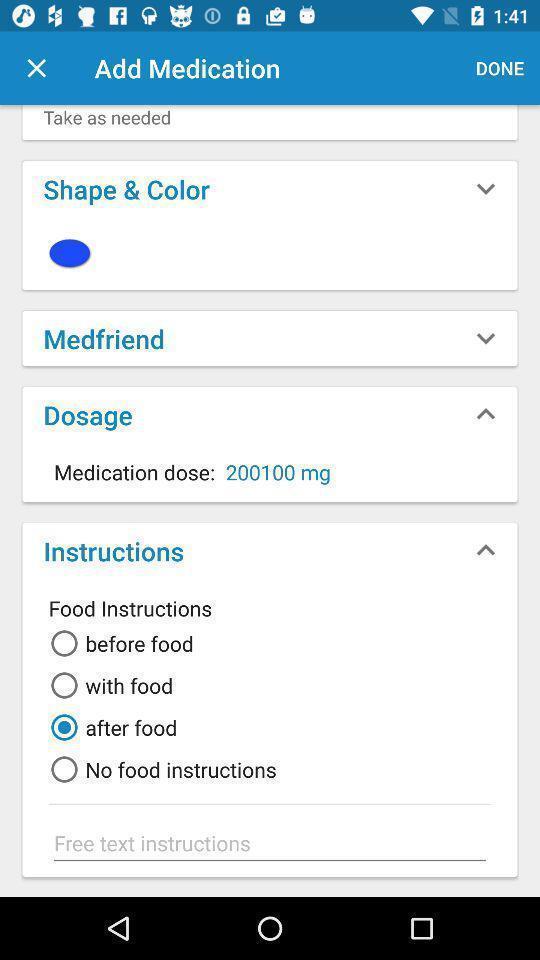Describe the visual elements of this screenshot. Page of a medicine remainder app. 